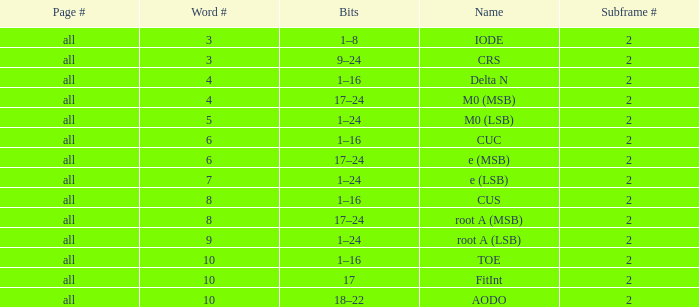What is the total subframe count with Bits of 18–22? 2.0. 